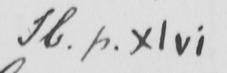What is written in this line of handwriting? H . p . xlvi 